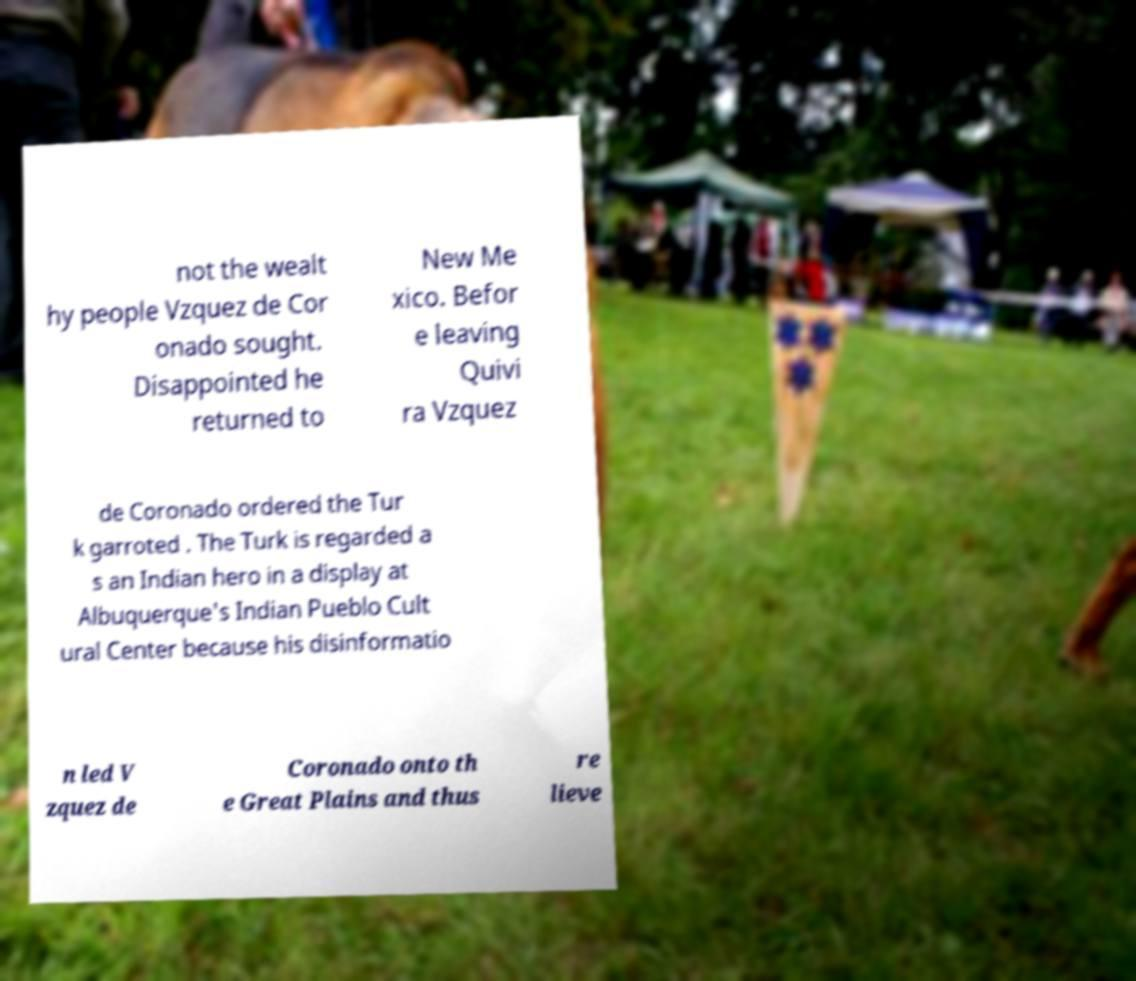Can you read and provide the text displayed in the image?This photo seems to have some interesting text. Can you extract and type it out for me? not the wealt hy people Vzquez de Cor onado sought. Disappointed he returned to New Me xico. Befor e leaving Quivi ra Vzquez de Coronado ordered the Tur k garroted . The Turk is regarded a s an Indian hero in a display at Albuquerque's Indian Pueblo Cult ural Center because his disinformatio n led V zquez de Coronado onto th e Great Plains and thus re lieve 